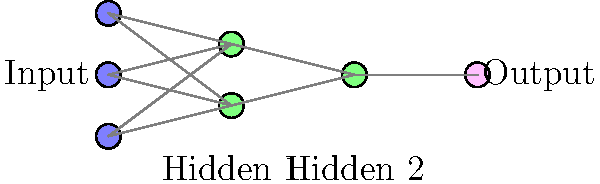Analyze the neural network architecture diagram provided. What is the total number of trainable parameters (weights and biases) in this network, assuming each neuron has a bias term and all possible connections between layers are present? To calculate the total number of trainable parameters, we need to count the weights and biases for each layer:

1. Count the number of neurons in each layer:
   - Input layer: 3 neurons
   - First hidden layer: 2 neurons
   - Second hidden layer: 1 neuron
   - Output layer: 1 neuron

2. Calculate weights between layers:
   - Input to first hidden layer: $3 \times 2 = 6$ weights
   - First hidden to second hidden layer: $2 \times 1 = 2$ weights
   - Second hidden to output layer: $1 \times 1 = 1$ weight

3. Calculate biases:
   - First hidden layer: 2 biases
   - Second hidden layer: 1 bias
   - Output layer: 1 bias

4. Sum up all trainable parameters:
   Total = (6 + 2 + 1) weights + (2 + 1 + 1) biases
         = 9 weights + 4 biases
         = 13 trainable parameters
Answer: 13 trainable parameters 